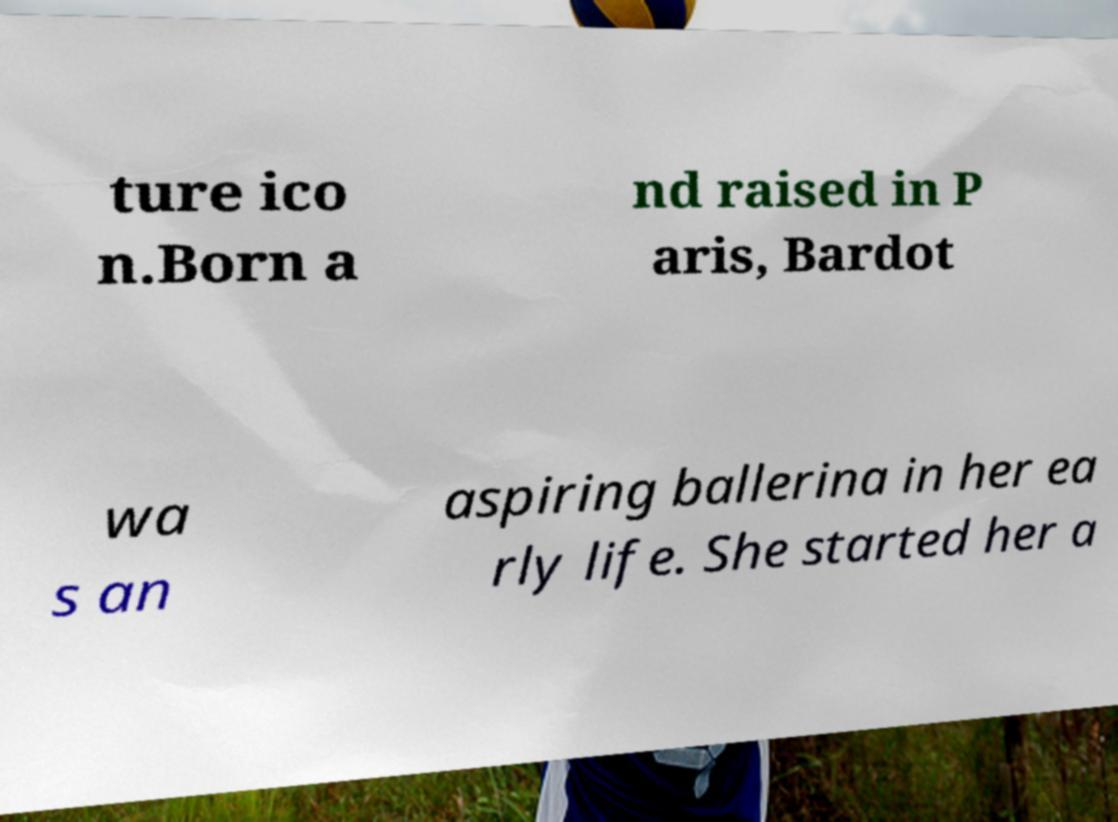Can you accurately transcribe the text from the provided image for me? ture ico n.Born a nd raised in P aris, Bardot wa s an aspiring ballerina in her ea rly life. She started her a 